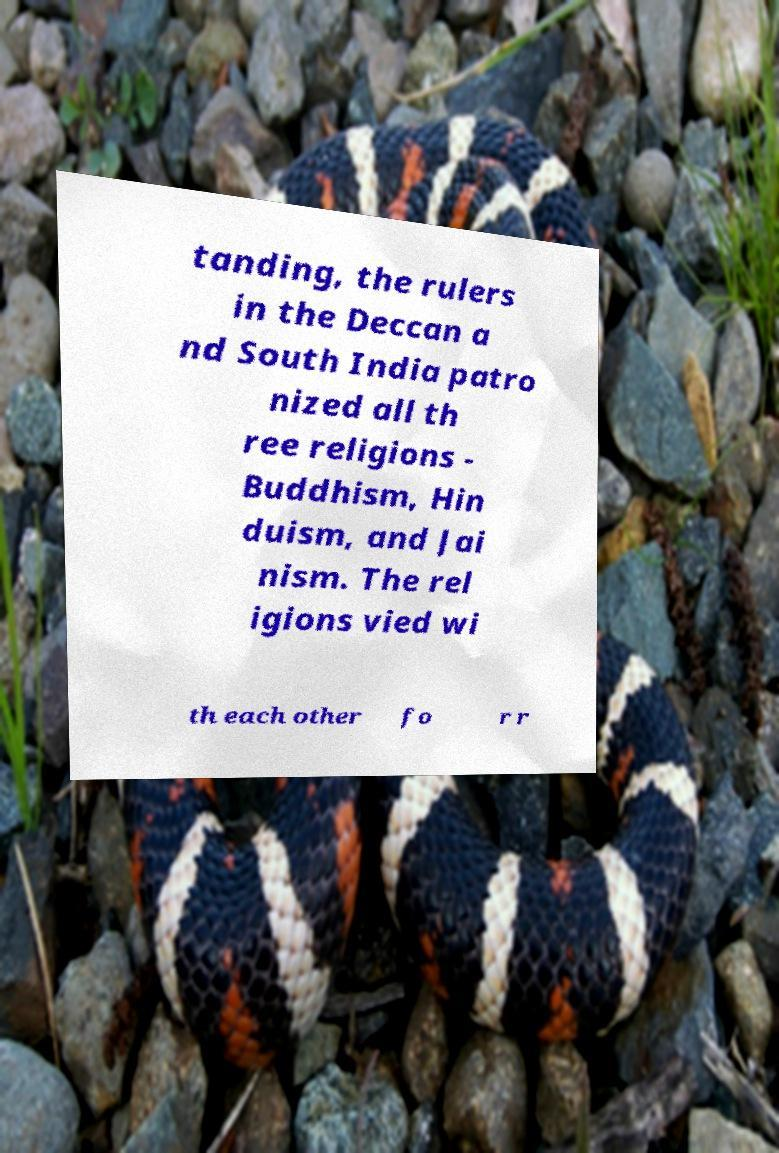Please read and relay the text visible in this image. What does it say? tanding, the rulers in the Deccan a nd South India patro nized all th ree religions - Buddhism, Hin duism, and Jai nism. The rel igions vied wi th each other fo r r 